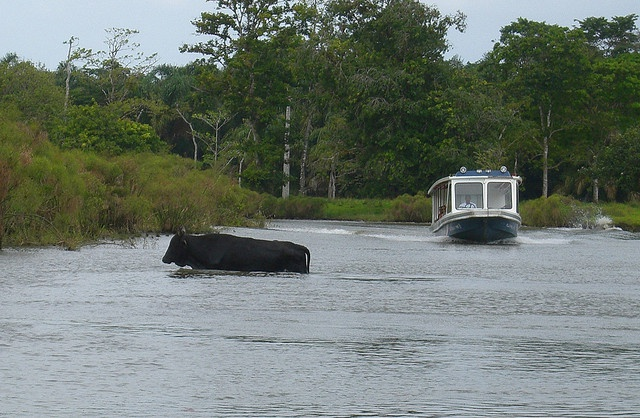Describe the objects in this image and their specific colors. I can see boat in lightgray, gray, black, and darkgray tones, cow in lightgray, black, gray, and darkgray tones, people in lightgray, gray, and darkgray tones, and people in lightgray, black, and gray tones in this image. 